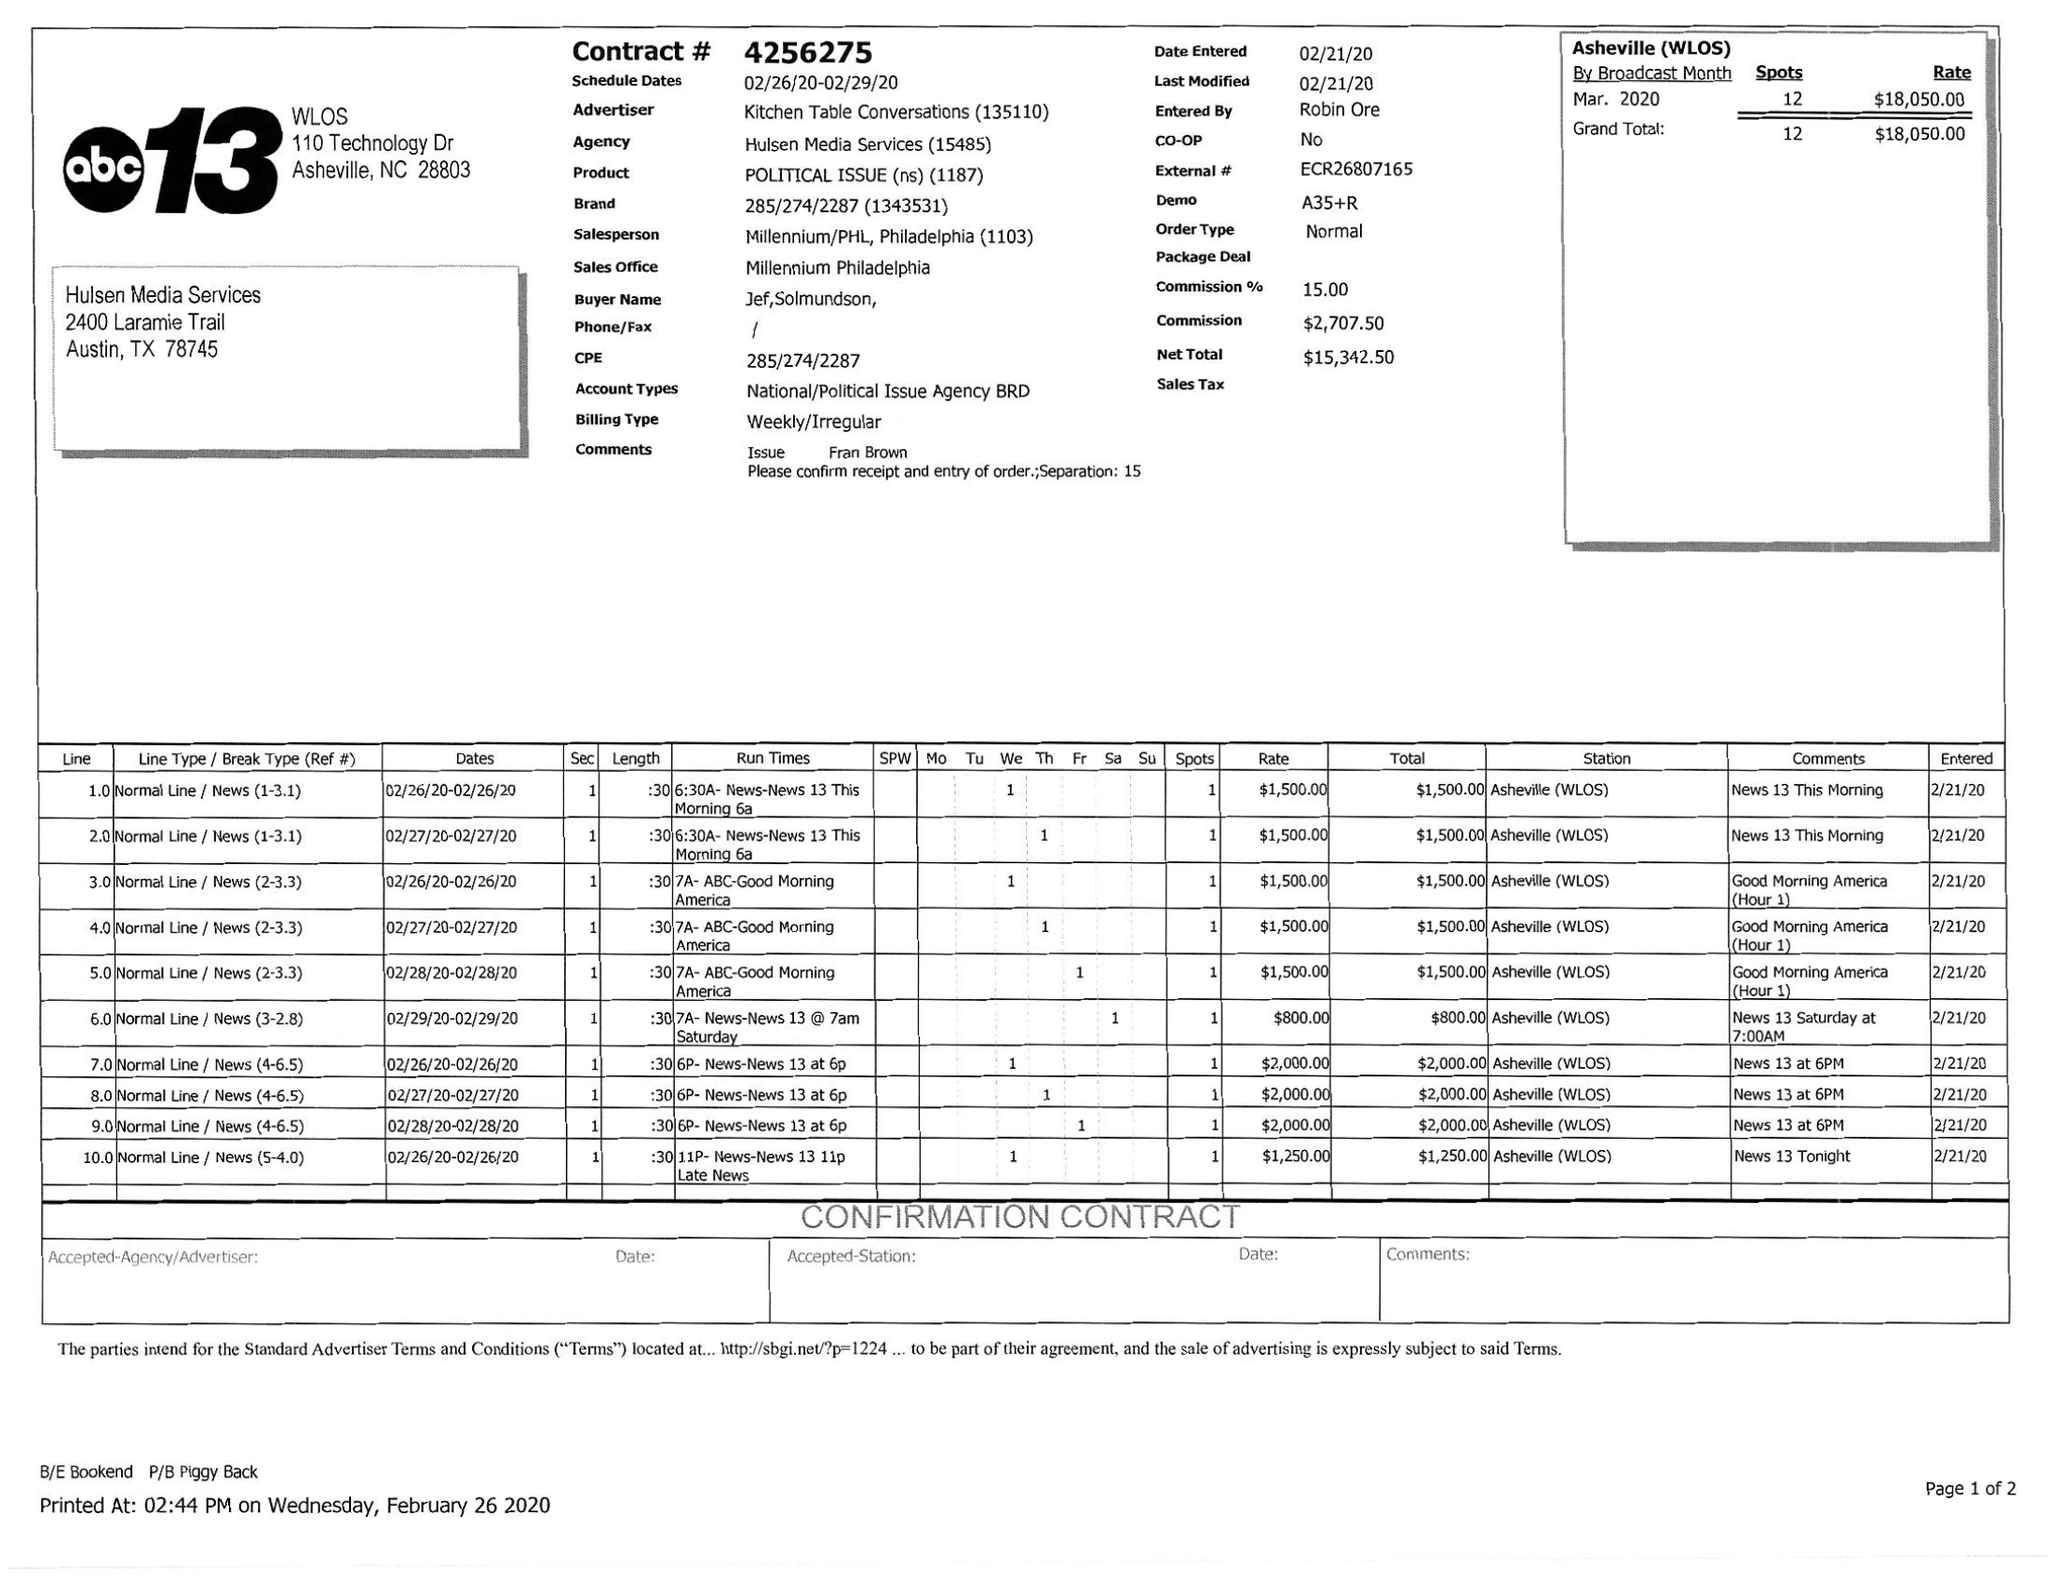What is the value for the flight_to?
Answer the question using a single word or phrase. 02/29/20 